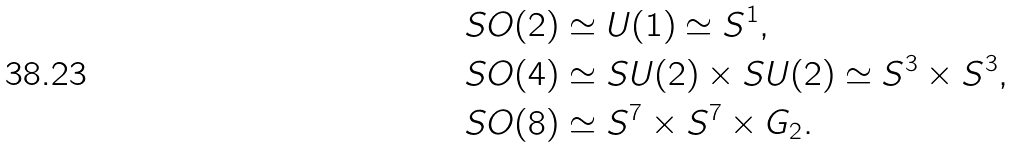Convert formula to latex. <formula><loc_0><loc_0><loc_500><loc_500>& S O ( 2 ) \simeq U ( 1 ) \simeq S ^ { 1 } , \\ & S O ( 4 ) \simeq S U ( 2 ) \times S U ( 2 ) \simeq S ^ { 3 } \times S ^ { 3 } , \\ & S O ( 8 ) \simeq S ^ { 7 } \times S ^ { 7 } \times G _ { 2 } .</formula> 